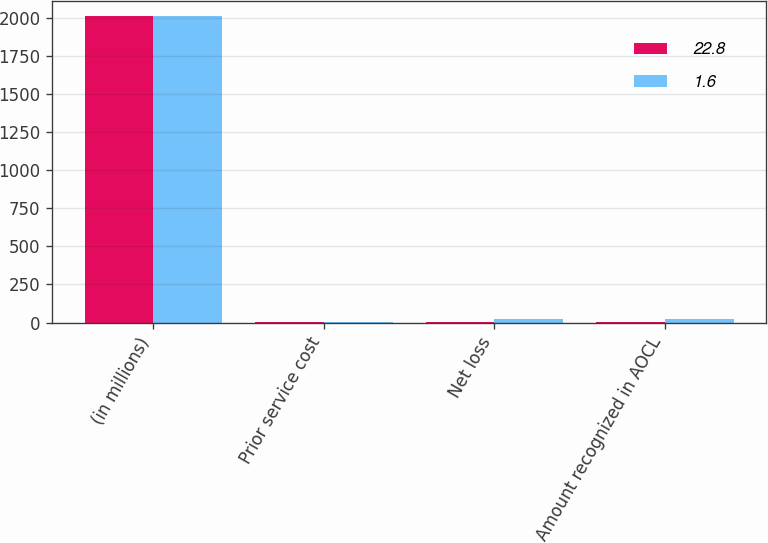<chart> <loc_0><loc_0><loc_500><loc_500><stacked_bar_chart><ecel><fcel>(in millions)<fcel>Prior service cost<fcel>Net loss<fcel>Amount recognized in AOCL<nl><fcel>22.8<fcel>2011<fcel>2.2<fcel>3.8<fcel>1.6<nl><fcel>1.6<fcel>2010<fcel>2.5<fcel>20.3<fcel>22.8<nl></chart> 